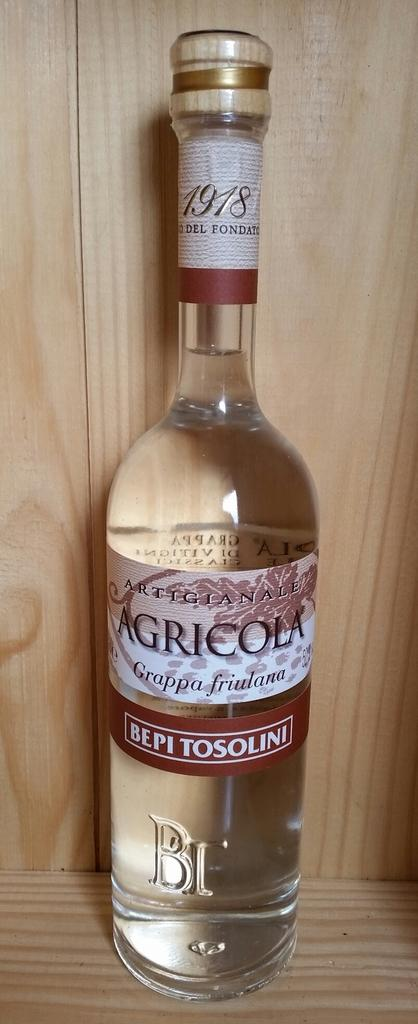<image>
Present a compact description of the photo's key features. A bottle of Agricola Grappa friulana is on a wooden shelf. 